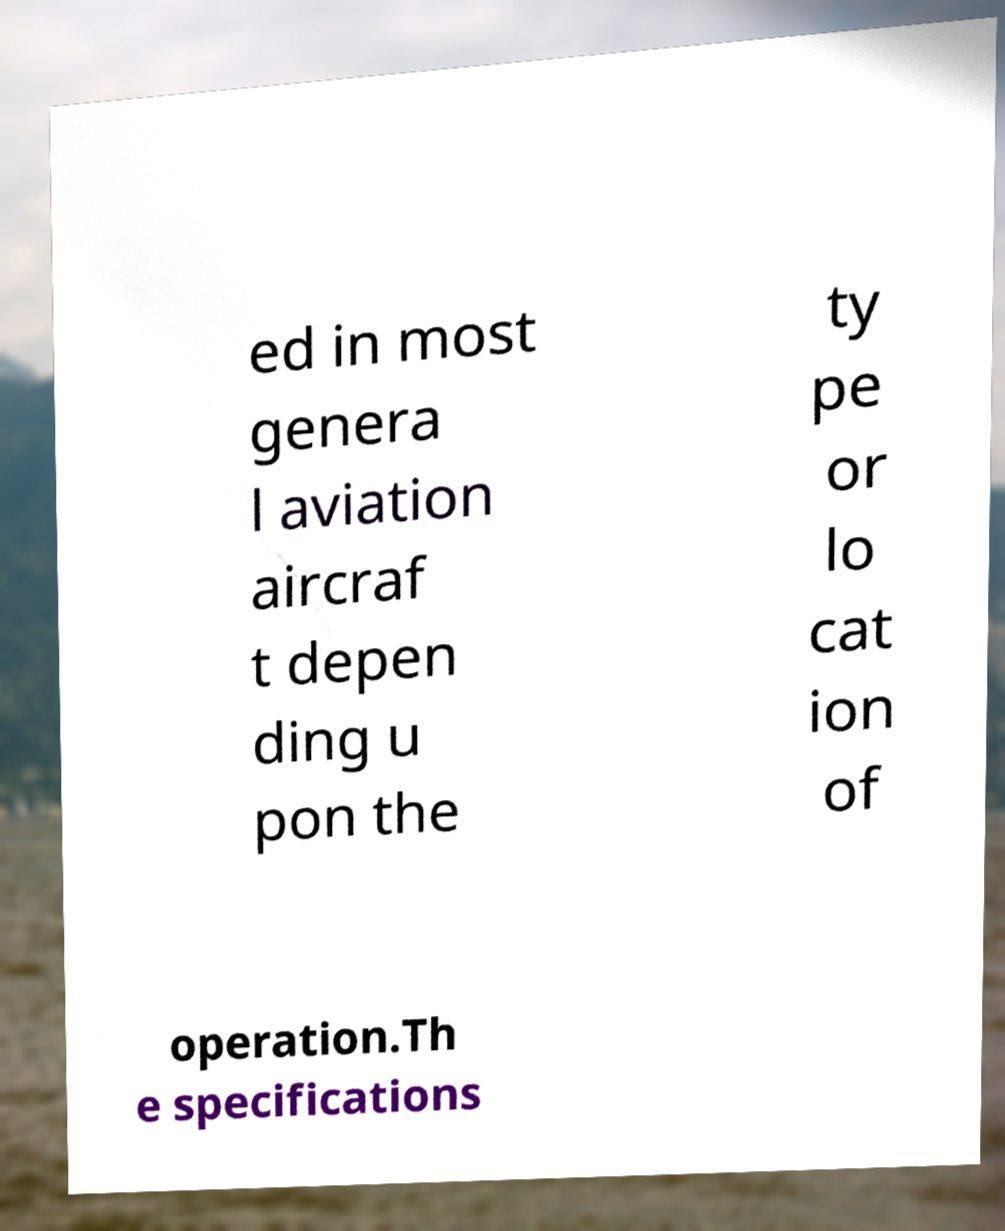Can you read and provide the text displayed in the image?This photo seems to have some interesting text. Can you extract and type it out for me? ed in most genera l aviation aircraf t depen ding u pon the ty pe or lo cat ion of operation.Th e specifications 